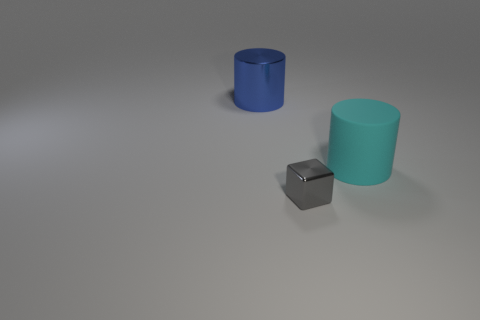Subtract 1 cylinders. How many cylinders are left? 1 Add 2 brown blocks. How many objects exist? 5 Subtract all cylinders. How many objects are left? 1 Subtract all cyan cylinders. How many cylinders are left? 1 Add 2 tiny metal blocks. How many tiny metal blocks exist? 3 Subtract 0 brown cubes. How many objects are left? 3 Subtract all purple cubes. Subtract all gray balls. How many cubes are left? 1 Subtract all large red cylinders. Subtract all blue cylinders. How many objects are left? 2 Add 1 cyan rubber cylinders. How many cyan rubber cylinders are left? 2 